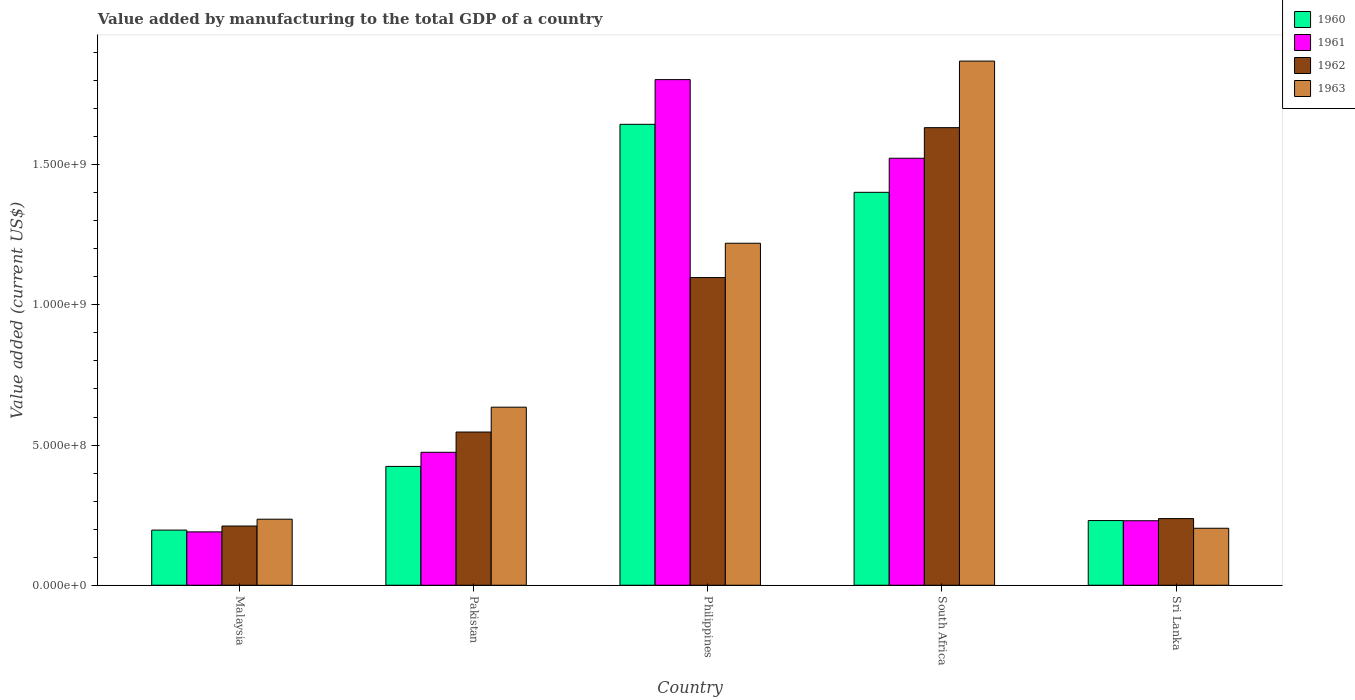Are the number of bars per tick equal to the number of legend labels?
Your answer should be compact. Yes. What is the label of the 5th group of bars from the left?
Offer a terse response. Sri Lanka. What is the value added by manufacturing to the total GDP in 1961 in Philippines?
Your answer should be very brief. 1.80e+09. Across all countries, what is the maximum value added by manufacturing to the total GDP in 1963?
Your answer should be compact. 1.87e+09. Across all countries, what is the minimum value added by manufacturing to the total GDP in 1961?
Your answer should be very brief. 1.90e+08. In which country was the value added by manufacturing to the total GDP in 1960 minimum?
Give a very brief answer. Malaysia. What is the total value added by manufacturing to the total GDP in 1961 in the graph?
Make the answer very short. 4.22e+09. What is the difference between the value added by manufacturing to the total GDP in 1962 in Pakistan and that in Philippines?
Give a very brief answer. -5.51e+08. What is the difference between the value added by manufacturing to the total GDP in 1962 in Philippines and the value added by manufacturing to the total GDP in 1960 in South Africa?
Offer a terse response. -3.04e+08. What is the average value added by manufacturing to the total GDP in 1962 per country?
Keep it short and to the point. 7.45e+08. What is the difference between the value added by manufacturing to the total GDP of/in 1963 and value added by manufacturing to the total GDP of/in 1962 in South Africa?
Provide a short and direct response. 2.37e+08. What is the ratio of the value added by manufacturing to the total GDP in 1961 in Malaysia to that in South Africa?
Give a very brief answer. 0.13. What is the difference between the highest and the second highest value added by manufacturing to the total GDP in 1963?
Your answer should be very brief. 1.23e+09. What is the difference between the highest and the lowest value added by manufacturing to the total GDP in 1962?
Your answer should be very brief. 1.42e+09. Is the sum of the value added by manufacturing to the total GDP in 1962 in South Africa and Sri Lanka greater than the maximum value added by manufacturing to the total GDP in 1961 across all countries?
Make the answer very short. Yes. What does the 4th bar from the left in South Africa represents?
Ensure brevity in your answer.  1963. Is it the case that in every country, the sum of the value added by manufacturing to the total GDP in 1963 and value added by manufacturing to the total GDP in 1961 is greater than the value added by manufacturing to the total GDP in 1960?
Ensure brevity in your answer.  Yes. What is the difference between two consecutive major ticks on the Y-axis?
Keep it short and to the point. 5.00e+08. Does the graph contain grids?
Ensure brevity in your answer.  No. Where does the legend appear in the graph?
Make the answer very short. Top right. What is the title of the graph?
Your answer should be very brief. Value added by manufacturing to the total GDP of a country. Does "1991" appear as one of the legend labels in the graph?
Your answer should be compact. No. What is the label or title of the X-axis?
Your answer should be compact. Country. What is the label or title of the Y-axis?
Provide a succinct answer. Value added (current US$). What is the Value added (current US$) in 1960 in Malaysia?
Provide a succinct answer. 1.97e+08. What is the Value added (current US$) of 1961 in Malaysia?
Give a very brief answer. 1.90e+08. What is the Value added (current US$) of 1962 in Malaysia?
Your answer should be compact. 2.11e+08. What is the Value added (current US$) of 1963 in Malaysia?
Provide a short and direct response. 2.36e+08. What is the Value added (current US$) in 1960 in Pakistan?
Your answer should be very brief. 4.24e+08. What is the Value added (current US$) in 1961 in Pakistan?
Give a very brief answer. 4.74e+08. What is the Value added (current US$) of 1962 in Pakistan?
Your answer should be compact. 5.46e+08. What is the Value added (current US$) in 1963 in Pakistan?
Provide a short and direct response. 6.35e+08. What is the Value added (current US$) of 1960 in Philippines?
Keep it short and to the point. 1.64e+09. What is the Value added (current US$) in 1961 in Philippines?
Ensure brevity in your answer.  1.80e+09. What is the Value added (current US$) in 1962 in Philippines?
Offer a very short reply. 1.10e+09. What is the Value added (current US$) in 1963 in Philippines?
Provide a succinct answer. 1.22e+09. What is the Value added (current US$) in 1960 in South Africa?
Give a very brief answer. 1.40e+09. What is the Value added (current US$) of 1961 in South Africa?
Offer a very short reply. 1.52e+09. What is the Value added (current US$) of 1962 in South Africa?
Your response must be concise. 1.63e+09. What is the Value added (current US$) of 1963 in South Africa?
Your answer should be very brief. 1.87e+09. What is the Value added (current US$) of 1960 in Sri Lanka?
Offer a very short reply. 2.31e+08. What is the Value added (current US$) in 1961 in Sri Lanka?
Keep it short and to the point. 2.30e+08. What is the Value added (current US$) in 1962 in Sri Lanka?
Ensure brevity in your answer.  2.38e+08. What is the Value added (current US$) of 1963 in Sri Lanka?
Keep it short and to the point. 2.03e+08. Across all countries, what is the maximum Value added (current US$) of 1960?
Offer a terse response. 1.64e+09. Across all countries, what is the maximum Value added (current US$) in 1961?
Make the answer very short. 1.80e+09. Across all countries, what is the maximum Value added (current US$) of 1962?
Make the answer very short. 1.63e+09. Across all countries, what is the maximum Value added (current US$) in 1963?
Offer a very short reply. 1.87e+09. Across all countries, what is the minimum Value added (current US$) of 1960?
Ensure brevity in your answer.  1.97e+08. Across all countries, what is the minimum Value added (current US$) in 1961?
Offer a terse response. 1.90e+08. Across all countries, what is the minimum Value added (current US$) in 1962?
Your answer should be very brief. 2.11e+08. Across all countries, what is the minimum Value added (current US$) of 1963?
Provide a succinct answer. 2.03e+08. What is the total Value added (current US$) of 1960 in the graph?
Offer a very short reply. 3.90e+09. What is the total Value added (current US$) in 1961 in the graph?
Give a very brief answer. 4.22e+09. What is the total Value added (current US$) of 1962 in the graph?
Make the answer very short. 3.72e+09. What is the total Value added (current US$) of 1963 in the graph?
Your answer should be very brief. 4.16e+09. What is the difference between the Value added (current US$) of 1960 in Malaysia and that in Pakistan?
Make the answer very short. -2.27e+08. What is the difference between the Value added (current US$) of 1961 in Malaysia and that in Pakistan?
Make the answer very short. -2.84e+08. What is the difference between the Value added (current US$) of 1962 in Malaysia and that in Pakistan?
Your answer should be very brief. -3.35e+08. What is the difference between the Value added (current US$) in 1963 in Malaysia and that in Pakistan?
Your answer should be compact. -3.99e+08. What is the difference between the Value added (current US$) of 1960 in Malaysia and that in Philippines?
Keep it short and to the point. -1.45e+09. What is the difference between the Value added (current US$) of 1961 in Malaysia and that in Philippines?
Your answer should be compact. -1.61e+09. What is the difference between the Value added (current US$) in 1962 in Malaysia and that in Philippines?
Your answer should be very brief. -8.86e+08. What is the difference between the Value added (current US$) of 1963 in Malaysia and that in Philippines?
Ensure brevity in your answer.  -9.84e+08. What is the difference between the Value added (current US$) in 1960 in Malaysia and that in South Africa?
Make the answer very short. -1.20e+09. What is the difference between the Value added (current US$) in 1961 in Malaysia and that in South Africa?
Your answer should be very brief. -1.33e+09. What is the difference between the Value added (current US$) of 1962 in Malaysia and that in South Africa?
Your response must be concise. -1.42e+09. What is the difference between the Value added (current US$) in 1963 in Malaysia and that in South Africa?
Ensure brevity in your answer.  -1.63e+09. What is the difference between the Value added (current US$) in 1960 in Malaysia and that in Sri Lanka?
Offer a terse response. -3.40e+07. What is the difference between the Value added (current US$) of 1961 in Malaysia and that in Sri Lanka?
Provide a short and direct response. -3.97e+07. What is the difference between the Value added (current US$) of 1962 in Malaysia and that in Sri Lanka?
Offer a terse response. -2.64e+07. What is the difference between the Value added (current US$) in 1963 in Malaysia and that in Sri Lanka?
Your answer should be compact. 3.23e+07. What is the difference between the Value added (current US$) in 1960 in Pakistan and that in Philippines?
Offer a terse response. -1.22e+09. What is the difference between the Value added (current US$) in 1961 in Pakistan and that in Philippines?
Provide a succinct answer. -1.33e+09. What is the difference between the Value added (current US$) in 1962 in Pakistan and that in Philippines?
Make the answer very short. -5.51e+08. What is the difference between the Value added (current US$) in 1963 in Pakistan and that in Philippines?
Ensure brevity in your answer.  -5.85e+08. What is the difference between the Value added (current US$) of 1960 in Pakistan and that in South Africa?
Give a very brief answer. -9.78e+08. What is the difference between the Value added (current US$) in 1961 in Pakistan and that in South Africa?
Ensure brevity in your answer.  -1.05e+09. What is the difference between the Value added (current US$) in 1962 in Pakistan and that in South Africa?
Give a very brief answer. -1.09e+09. What is the difference between the Value added (current US$) of 1963 in Pakistan and that in South Africa?
Offer a very short reply. -1.23e+09. What is the difference between the Value added (current US$) in 1960 in Pakistan and that in Sri Lanka?
Your response must be concise. 1.93e+08. What is the difference between the Value added (current US$) in 1961 in Pakistan and that in Sri Lanka?
Ensure brevity in your answer.  2.44e+08. What is the difference between the Value added (current US$) of 1962 in Pakistan and that in Sri Lanka?
Make the answer very short. 3.09e+08. What is the difference between the Value added (current US$) of 1963 in Pakistan and that in Sri Lanka?
Give a very brief answer. 4.32e+08. What is the difference between the Value added (current US$) of 1960 in Philippines and that in South Africa?
Your response must be concise. 2.43e+08. What is the difference between the Value added (current US$) of 1961 in Philippines and that in South Africa?
Provide a short and direct response. 2.80e+08. What is the difference between the Value added (current US$) of 1962 in Philippines and that in South Africa?
Your answer should be compact. -5.35e+08. What is the difference between the Value added (current US$) in 1963 in Philippines and that in South Africa?
Ensure brevity in your answer.  -6.50e+08. What is the difference between the Value added (current US$) in 1960 in Philippines and that in Sri Lanka?
Provide a short and direct response. 1.41e+09. What is the difference between the Value added (current US$) of 1961 in Philippines and that in Sri Lanka?
Ensure brevity in your answer.  1.57e+09. What is the difference between the Value added (current US$) in 1962 in Philippines and that in Sri Lanka?
Offer a terse response. 8.60e+08. What is the difference between the Value added (current US$) in 1963 in Philippines and that in Sri Lanka?
Your answer should be compact. 1.02e+09. What is the difference between the Value added (current US$) of 1960 in South Africa and that in Sri Lanka?
Offer a terse response. 1.17e+09. What is the difference between the Value added (current US$) in 1961 in South Africa and that in Sri Lanka?
Your answer should be very brief. 1.29e+09. What is the difference between the Value added (current US$) of 1962 in South Africa and that in Sri Lanka?
Keep it short and to the point. 1.39e+09. What is the difference between the Value added (current US$) of 1963 in South Africa and that in Sri Lanka?
Ensure brevity in your answer.  1.67e+09. What is the difference between the Value added (current US$) in 1960 in Malaysia and the Value added (current US$) in 1961 in Pakistan?
Provide a succinct answer. -2.78e+08. What is the difference between the Value added (current US$) in 1960 in Malaysia and the Value added (current US$) in 1962 in Pakistan?
Make the answer very short. -3.50e+08. What is the difference between the Value added (current US$) of 1960 in Malaysia and the Value added (current US$) of 1963 in Pakistan?
Your response must be concise. -4.38e+08. What is the difference between the Value added (current US$) of 1961 in Malaysia and the Value added (current US$) of 1962 in Pakistan?
Make the answer very short. -3.56e+08. What is the difference between the Value added (current US$) in 1961 in Malaysia and the Value added (current US$) in 1963 in Pakistan?
Ensure brevity in your answer.  -4.45e+08. What is the difference between the Value added (current US$) of 1962 in Malaysia and the Value added (current US$) of 1963 in Pakistan?
Provide a succinct answer. -4.24e+08. What is the difference between the Value added (current US$) of 1960 in Malaysia and the Value added (current US$) of 1961 in Philippines?
Make the answer very short. -1.61e+09. What is the difference between the Value added (current US$) in 1960 in Malaysia and the Value added (current US$) in 1962 in Philippines?
Offer a terse response. -9.01e+08. What is the difference between the Value added (current US$) in 1960 in Malaysia and the Value added (current US$) in 1963 in Philippines?
Your answer should be very brief. -1.02e+09. What is the difference between the Value added (current US$) of 1961 in Malaysia and the Value added (current US$) of 1962 in Philippines?
Offer a terse response. -9.07e+08. What is the difference between the Value added (current US$) of 1961 in Malaysia and the Value added (current US$) of 1963 in Philippines?
Offer a very short reply. -1.03e+09. What is the difference between the Value added (current US$) in 1962 in Malaysia and the Value added (current US$) in 1963 in Philippines?
Ensure brevity in your answer.  -1.01e+09. What is the difference between the Value added (current US$) of 1960 in Malaysia and the Value added (current US$) of 1961 in South Africa?
Keep it short and to the point. -1.33e+09. What is the difference between the Value added (current US$) in 1960 in Malaysia and the Value added (current US$) in 1962 in South Africa?
Your answer should be compact. -1.44e+09. What is the difference between the Value added (current US$) of 1960 in Malaysia and the Value added (current US$) of 1963 in South Africa?
Your response must be concise. -1.67e+09. What is the difference between the Value added (current US$) in 1961 in Malaysia and the Value added (current US$) in 1962 in South Africa?
Ensure brevity in your answer.  -1.44e+09. What is the difference between the Value added (current US$) of 1961 in Malaysia and the Value added (current US$) of 1963 in South Africa?
Offer a terse response. -1.68e+09. What is the difference between the Value added (current US$) in 1962 in Malaysia and the Value added (current US$) in 1963 in South Africa?
Offer a very short reply. -1.66e+09. What is the difference between the Value added (current US$) in 1960 in Malaysia and the Value added (current US$) in 1961 in Sri Lanka?
Your answer should be compact. -3.34e+07. What is the difference between the Value added (current US$) of 1960 in Malaysia and the Value added (current US$) of 1962 in Sri Lanka?
Ensure brevity in your answer.  -4.10e+07. What is the difference between the Value added (current US$) of 1960 in Malaysia and the Value added (current US$) of 1963 in Sri Lanka?
Make the answer very short. -6.57e+06. What is the difference between the Value added (current US$) in 1961 in Malaysia and the Value added (current US$) in 1962 in Sri Lanka?
Offer a terse response. -4.73e+07. What is the difference between the Value added (current US$) in 1961 in Malaysia and the Value added (current US$) in 1963 in Sri Lanka?
Provide a succinct answer. -1.28e+07. What is the difference between the Value added (current US$) of 1962 in Malaysia and the Value added (current US$) of 1963 in Sri Lanka?
Your answer should be compact. 8.02e+06. What is the difference between the Value added (current US$) of 1960 in Pakistan and the Value added (current US$) of 1961 in Philippines?
Offer a very short reply. -1.38e+09. What is the difference between the Value added (current US$) of 1960 in Pakistan and the Value added (current US$) of 1962 in Philippines?
Ensure brevity in your answer.  -6.74e+08. What is the difference between the Value added (current US$) of 1960 in Pakistan and the Value added (current US$) of 1963 in Philippines?
Provide a succinct answer. -7.96e+08. What is the difference between the Value added (current US$) of 1961 in Pakistan and the Value added (current US$) of 1962 in Philippines?
Ensure brevity in your answer.  -6.23e+08. What is the difference between the Value added (current US$) of 1961 in Pakistan and the Value added (current US$) of 1963 in Philippines?
Offer a very short reply. -7.46e+08. What is the difference between the Value added (current US$) of 1962 in Pakistan and the Value added (current US$) of 1963 in Philippines?
Offer a terse response. -6.73e+08. What is the difference between the Value added (current US$) in 1960 in Pakistan and the Value added (current US$) in 1961 in South Africa?
Your response must be concise. -1.10e+09. What is the difference between the Value added (current US$) in 1960 in Pakistan and the Value added (current US$) in 1962 in South Africa?
Give a very brief answer. -1.21e+09. What is the difference between the Value added (current US$) in 1960 in Pakistan and the Value added (current US$) in 1963 in South Africa?
Offer a very short reply. -1.45e+09. What is the difference between the Value added (current US$) of 1961 in Pakistan and the Value added (current US$) of 1962 in South Africa?
Give a very brief answer. -1.16e+09. What is the difference between the Value added (current US$) of 1961 in Pakistan and the Value added (current US$) of 1963 in South Africa?
Your answer should be very brief. -1.40e+09. What is the difference between the Value added (current US$) of 1962 in Pakistan and the Value added (current US$) of 1963 in South Africa?
Your response must be concise. -1.32e+09. What is the difference between the Value added (current US$) in 1960 in Pakistan and the Value added (current US$) in 1961 in Sri Lanka?
Your response must be concise. 1.94e+08. What is the difference between the Value added (current US$) in 1960 in Pakistan and the Value added (current US$) in 1962 in Sri Lanka?
Provide a short and direct response. 1.86e+08. What is the difference between the Value added (current US$) in 1960 in Pakistan and the Value added (current US$) in 1963 in Sri Lanka?
Make the answer very short. 2.21e+08. What is the difference between the Value added (current US$) in 1961 in Pakistan and the Value added (current US$) in 1962 in Sri Lanka?
Your answer should be compact. 2.37e+08. What is the difference between the Value added (current US$) in 1961 in Pakistan and the Value added (current US$) in 1963 in Sri Lanka?
Give a very brief answer. 2.71e+08. What is the difference between the Value added (current US$) of 1962 in Pakistan and the Value added (current US$) of 1963 in Sri Lanka?
Your answer should be very brief. 3.43e+08. What is the difference between the Value added (current US$) in 1960 in Philippines and the Value added (current US$) in 1961 in South Africa?
Offer a very short reply. 1.21e+08. What is the difference between the Value added (current US$) of 1960 in Philippines and the Value added (current US$) of 1962 in South Africa?
Give a very brief answer. 1.19e+07. What is the difference between the Value added (current US$) in 1960 in Philippines and the Value added (current US$) in 1963 in South Africa?
Keep it short and to the point. -2.26e+08. What is the difference between the Value added (current US$) in 1961 in Philippines and the Value added (current US$) in 1962 in South Africa?
Keep it short and to the point. 1.71e+08. What is the difference between the Value added (current US$) in 1961 in Philippines and the Value added (current US$) in 1963 in South Africa?
Keep it short and to the point. -6.61e+07. What is the difference between the Value added (current US$) in 1962 in Philippines and the Value added (current US$) in 1963 in South Africa?
Your response must be concise. -7.72e+08. What is the difference between the Value added (current US$) in 1960 in Philippines and the Value added (current US$) in 1961 in Sri Lanka?
Give a very brief answer. 1.41e+09. What is the difference between the Value added (current US$) in 1960 in Philippines and the Value added (current US$) in 1962 in Sri Lanka?
Provide a short and direct response. 1.41e+09. What is the difference between the Value added (current US$) of 1960 in Philippines and the Value added (current US$) of 1963 in Sri Lanka?
Provide a succinct answer. 1.44e+09. What is the difference between the Value added (current US$) of 1961 in Philippines and the Value added (current US$) of 1962 in Sri Lanka?
Give a very brief answer. 1.57e+09. What is the difference between the Value added (current US$) of 1961 in Philippines and the Value added (current US$) of 1963 in Sri Lanka?
Offer a terse response. 1.60e+09. What is the difference between the Value added (current US$) of 1962 in Philippines and the Value added (current US$) of 1963 in Sri Lanka?
Provide a short and direct response. 8.94e+08. What is the difference between the Value added (current US$) in 1960 in South Africa and the Value added (current US$) in 1961 in Sri Lanka?
Your answer should be compact. 1.17e+09. What is the difference between the Value added (current US$) of 1960 in South Africa and the Value added (current US$) of 1962 in Sri Lanka?
Your answer should be compact. 1.16e+09. What is the difference between the Value added (current US$) of 1960 in South Africa and the Value added (current US$) of 1963 in Sri Lanka?
Ensure brevity in your answer.  1.20e+09. What is the difference between the Value added (current US$) of 1961 in South Africa and the Value added (current US$) of 1962 in Sri Lanka?
Offer a terse response. 1.29e+09. What is the difference between the Value added (current US$) in 1961 in South Africa and the Value added (current US$) in 1963 in Sri Lanka?
Ensure brevity in your answer.  1.32e+09. What is the difference between the Value added (current US$) of 1962 in South Africa and the Value added (current US$) of 1963 in Sri Lanka?
Provide a short and direct response. 1.43e+09. What is the average Value added (current US$) in 1960 per country?
Provide a succinct answer. 7.79e+08. What is the average Value added (current US$) in 1961 per country?
Your answer should be very brief. 8.44e+08. What is the average Value added (current US$) of 1962 per country?
Provide a short and direct response. 7.45e+08. What is the average Value added (current US$) in 1963 per country?
Your answer should be compact. 8.33e+08. What is the difference between the Value added (current US$) in 1960 and Value added (current US$) in 1961 in Malaysia?
Give a very brief answer. 6.25e+06. What is the difference between the Value added (current US$) in 1960 and Value added (current US$) in 1962 in Malaysia?
Make the answer very short. -1.46e+07. What is the difference between the Value added (current US$) in 1960 and Value added (current US$) in 1963 in Malaysia?
Offer a terse response. -3.89e+07. What is the difference between the Value added (current US$) in 1961 and Value added (current US$) in 1962 in Malaysia?
Your answer should be very brief. -2.08e+07. What is the difference between the Value added (current US$) of 1961 and Value added (current US$) of 1963 in Malaysia?
Your answer should be compact. -4.52e+07. What is the difference between the Value added (current US$) in 1962 and Value added (current US$) in 1963 in Malaysia?
Your answer should be compact. -2.43e+07. What is the difference between the Value added (current US$) in 1960 and Value added (current US$) in 1961 in Pakistan?
Offer a terse response. -5.04e+07. What is the difference between the Value added (current US$) of 1960 and Value added (current US$) of 1962 in Pakistan?
Your response must be concise. -1.23e+08. What is the difference between the Value added (current US$) in 1960 and Value added (current US$) in 1963 in Pakistan?
Provide a succinct answer. -2.11e+08. What is the difference between the Value added (current US$) of 1961 and Value added (current US$) of 1962 in Pakistan?
Your response must be concise. -7.22e+07. What is the difference between the Value added (current US$) in 1961 and Value added (current US$) in 1963 in Pakistan?
Provide a short and direct response. -1.61e+08. What is the difference between the Value added (current US$) of 1962 and Value added (current US$) of 1963 in Pakistan?
Give a very brief answer. -8.86e+07. What is the difference between the Value added (current US$) of 1960 and Value added (current US$) of 1961 in Philippines?
Give a very brief answer. -1.59e+08. What is the difference between the Value added (current US$) of 1960 and Value added (current US$) of 1962 in Philippines?
Keep it short and to the point. 5.47e+08. What is the difference between the Value added (current US$) of 1960 and Value added (current US$) of 1963 in Philippines?
Give a very brief answer. 4.24e+08. What is the difference between the Value added (current US$) of 1961 and Value added (current US$) of 1962 in Philippines?
Provide a short and direct response. 7.06e+08. What is the difference between the Value added (current US$) in 1961 and Value added (current US$) in 1963 in Philippines?
Give a very brief answer. 5.84e+08. What is the difference between the Value added (current US$) in 1962 and Value added (current US$) in 1963 in Philippines?
Keep it short and to the point. -1.22e+08. What is the difference between the Value added (current US$) of 1960 and Value added (current US$) of 1961 in South Africa?
Provide a succinct answer. -1.21e+08. What is the difference between the Value added (current US$) in 1960 and Value added (current US$) in 1962 in South Africa?
Keep it short and to the point. -2.31e+08. What is the difference between the Value added (current US$) of 1960 and Value added (current US$) of 1963 in South Africa?
Your response must be concise. -4.68e+08. What is the difference between the Value added (current US$) of 1961 and Value added (current US$) of 1962 in South Africa?
Provide a succinct answer. -1.09e+08. What is the difference between the Value added (current US$) in 1961 and Value added (current US$) in 1963 in South Africa?
Provide a short and direct response. -3.47e+08. What is the difference between the Value added (current US$) of 1962 and Value added (current US$) of 1963 in South Africa?
Offer a very short reply. -2.37e+08. What is the difference between the Value added (current US$) of 1960 and Value added (current US$) of 1961 in Sri Lanka?
Your response must be concise. 6.30e+05. What is the difference between the Value added (current US$) in 1960 and Value added (current US$) in 1962 in Sri Lanka?
Provide a succinct answer. -6.98e+06. What is the difference between the Value added (current US$) in 1960 and Value added (current US$) in 1963 in Sri Lanka?
Ensure brevity in your answer.  2.75e+07. What is the difference between the Value added (current US$) in 1961 and Value added (current US$) in 1962 in Sri Lanka?
Provide a succinct answer. -7.61e+06. What is the difference between the Value added (current US$) of 1961 and Value added (current US$) of 1963 in Sri Lanka?
Make the answer very short. 2.68e+07. What is the difference between the Value added (current US$) of 1962 and Value added (current US$) of 1963 in Sri Lanka?
Ensure brevity in your answer.  3.45e+07. What is the ratio of the Value added (current US$) in 1960 in Malaysia to that in Pakistan?
Ensure brevity in your answer.  0.46. What is the ratio of the Value added (current US$) in 1961 in Malaysia to that in Pakistan?
Give a very brief answer. 0.4. What is the ratio of the Value added (current US$) in 1962 in Malaysia to that in Pakistan?
Offer a terse response. 0.39. What is the ratio of the Value added (current US$) in 1963 in Malaysia to that in Pakistan?
Make the answer very short. 0.37. What is the ratio of the Value added (current US$) of 1960 in Malaysia to that in Philippines?
Provide a short and direct response. 0.12. What is the ratio of the Value added (current US$) of 1961 in Malaysia to that in Philippines?
Your response must be concise. 0.11. What is the ratio of the Value added (current US$) in 1962 in Malaysia to that in Philippines?
Offer a very short reply. 0.19. What is the ratio of the Value added (current US$) of 1963 in Malaysia to that in Philippines?
Provide a succinct answer. 0.19. What is the ratio of the Value added (current US$) of 1960 in Malaysia to that in South Africa?
Make the answer very short. 0.14. What is the ratio of the Value added (current US$) in 1961 in Malaysia to that in South Africa?
Your answer should be very brief. 0.12. What is the ratio of the Value added (current US$) of 1962 in Malaysia to that in South Africa?
Your response must be concise. 0.13. What is the ratio of the Value added (current US$) of 1963 in Malaysia to that in South Africa?
Offer a terse response. 0.13. What is the ratio of the Value added (current US$) of 1960 in Malaysia to that in Sri Lanka?
Make the answer very short. 0.85. What is the ratio of the Value added (current US$) in 1961 in Malaysia to that in Sri Lanka?
Your answer should be compact. 0.83. What is the ratio of the Value added (current US$) of 1962 in Malaysia to that in Sri Lanka?
Your answer should be compact. 0.89. What is the ratio of the Value added (current US$) of 1963 in Malaysia to that in Sri Lanka?
Ensure brevity in your answer.  1.16. What is the ratio of the Value added (current US$) of 1960 in Pakistan to that in Philippines?
Your answer should be very brief. 0.26. What is the ratio of the Value added (current US$) in 1961 in Pakistan to that in Philippines?
Offer a very short reply. 0.26. What is the ratio of the Value added (current US$) of 1962 in Pakistan to that in Philippines?
Your answer should be very brief. 0.5. What is the ratio of the Value added (current US$) of 1963 in Pakistan to that in Philippines?
Ensure brevity in your answer.  0.52. What is the ratio of the Value added (current US$) in 1960 in Pakistan to that in South Africa?
Ensure brevity in your answer.  0.3. What is the ratio of the Value added (current US$) of 1961 in Pakistan to that in South Africa?
Make the answer very short. 0.31. What is the ratio of the Value added (current US$) of 1962 in Pakistan to that in South Africa?
Keep it short and to the point. 0.33. What is the ratio of the Value added (current US$) of 1963 in Pakistan to that in South Africa?
Ensure brevity in your answer.  0.34. What is the ratio of the Value added (current US$) of 1960 in Pakistan to that in Sri Lanka?
Offer a very short reply. 1.84. What is the ratio of the Value added (current US$) of 1961 in Pakistan to that in Sri Lanka?
Provide a succinct answer. 2.06. What is the ratio of the Value added (current US$) in 1962 in Pakistan to that in Sri Lanka?
Your response must be concise. 2.3. What is the ratio of the Value added (current US$) in 1963 in Pakistan to that in Sri Lanka?
Offer a terse response. 3.13. What is the ratio of the Value added (current US$) of 1960 in Philippines to that in South Africa?
Provide a succinct answer. 1.17. What is the ratio of the Value added (current US$) of 1961 in Philippines to that in South Africa?
Keep it short and to the point. 1.18. What is the ratio of the Value added (current US$) of 1962 in Philippines to that in South Africa?
Provide a short and direct response. 0.67. What is the ratio of the Value added (current US$) of 1963 in Philippines to that in South Africa?
Your answer should be compact. 0.65. What is the ratio of the Value added (current US$) of 1960 in Philippines to that in Sri Lanka?
Offer a very short reply. 7.13. What is the ratio of the Value added (current US$) of 1961 in Philippines to that in Sri Lanka?
Make the answer very short. 7.84. What is the ratio of the Value added (current US$) in 1962 in Philippines to that in Sri Lanka?
Ensure brevity in your answer.  4.62. What is the ratio of the Value added (current US$) of 1963 in Philippines to that in Sri Lanka?
Offer a terse response. 6. What is the ratio of the Value added (current US$) of 1960 in South Africa to that in Sri Lanka?
Offer a terse response. 6.08. What is the ratio of the Value added (current US$) of 1961 in South Africa to that in Sri Lanka?
Give a very brief answer. 6.62. What is the ratio of the Value added (current US$) in 1962 in South Africa to that in Sri Lanka?
Your answer should be compact. 6.87. What is the ratio of the Value added (current US$) of 1963 in South Africa to that in Sri Lanka?
Your response must be concise. 9.2. What is the difference between the highest and the second highest Value added (current US$) of 1960?
Offer a terse response. 2.43e+08. What is the difference between the highest and the second highest Value added (current US$) in 1961?
Offer a very short reply. 2.80e+08. What is the difference between the highest and the second highest Value added (current US$) in 1962?
Give a very brief answer. 5.35e+08. What is the difference between the highest and the second highest Value added (current US$) of 1963?
Offer a terse response. 6.50e+08. What is the difference between the highest and the lowest Value added (current US$) in 1960?
Give a very brief answer. 1.45e+09. What is the difference between the highest and the lowest Value added (current US$) of 1961?
Make the answer very short. 1.61e+09. What is the difference between the highest and the lowest Value added (current US$) of 1962?
Keep it short and to the point. 1.42e+09. What is the difference between the highest and the lowest Value added (current US$) in 1963?
Your answer should be very brief. 1.67e+09. 